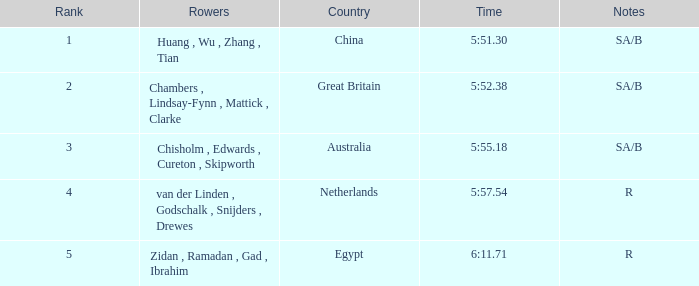In which country is the rank greater than 4? Egypt. 